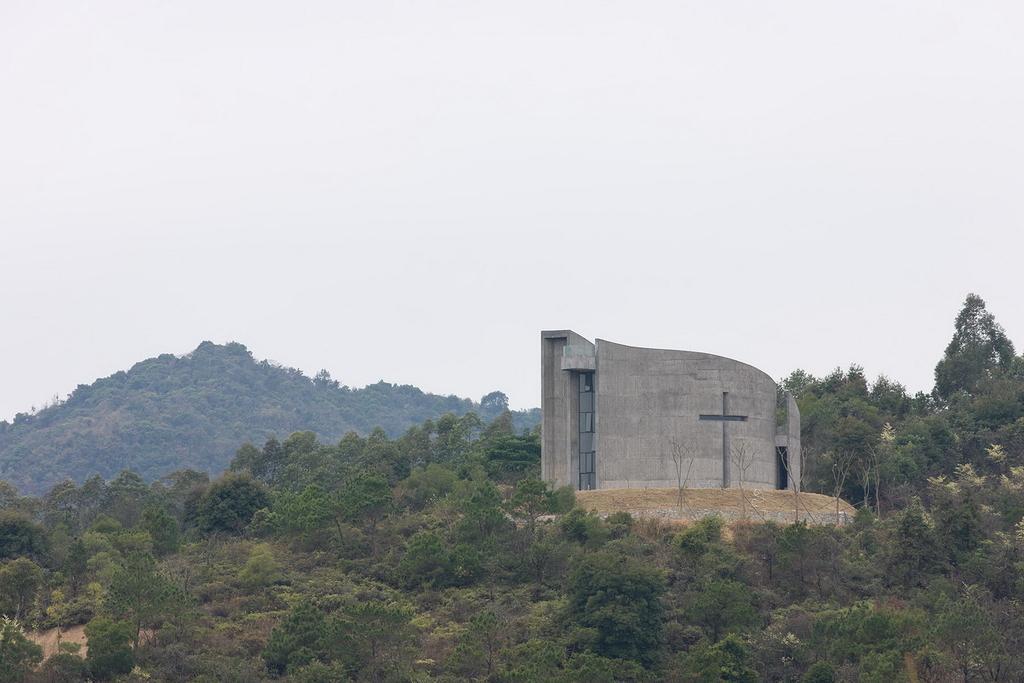In one or two sentences, can you explain what this image depicts? This picture is clicked outside. In the foreground we can see the plants. In the center we can see an object seems to be the house. In the background we can see the sky, trees and some other objects. 